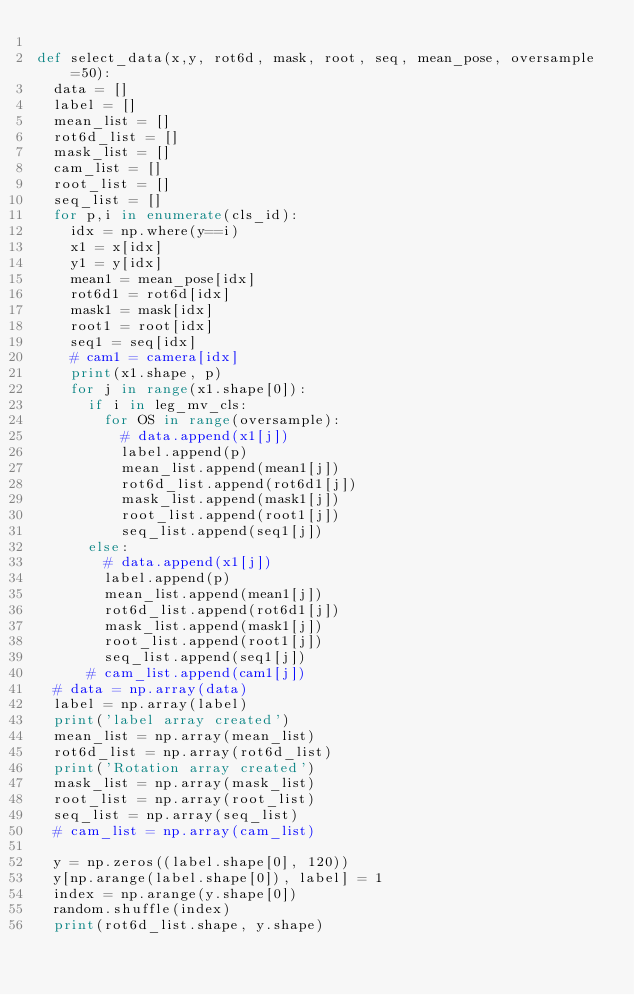<code> <loc_0><loc_0><loc_500><loc_500><_Python_>
def select_data(x,y, rot6d, mask, root, seq, mean_pose, oversample=50):
	data = []
	label = []
	mean_list = []
	rot6d_list = []
	mask_list = []
	cam_list = []
	root_list = []
	seq_list = []
	for p,i in enumerate(cls_id):
		idx = np.where(y==i)
		x1 = x[idx]
		y1 = y[idx]
		mean1 = mean_pose[idx]
		rot6d1 = rot6d[idx]
		mask1 = mask[idx]
		root1 = root[idx]
		seq1 = seq[idx]
		# cam1 = camera[idx]
		print(x1.shape, p)
		for j in range(x1.shape[0]):
			if i in leg_mv_cls:
				for OS in range(oversample):
					# data.append(x1[j])
					label.append(p)
					mean_list.append(mean1[j])
					rot6d_list.append(rot6d1[j])
					mask_list.append(mask1[j])
					root_list.append(root1[j])
					seq_list.append(seq1[j])
			else:
				# data.append(x1[j])
				label.append(p)
				mean_list.append(mean1[j])
				rot6d_list.append(rot6d1[j])
				mask_list.append(mask1[j])
				root_list.append(root1[j])
				seq_list.append(seq1[j])
			# cam_list.append(cam1[j])
	# data = np.array(data)
	label = np.array(label)
	print('label array created')
	mean_list = np.array(mean_list)
	rot6d_list = np.array(rot6d_list)
	print('Rotation array created')
	mask_list = np.array(mask_list)
	root_list = np.array(root_list)
	seq_list = np.array(seq_list)
	# cam_list = np.array(cam_list)

	y = np.zeros((label.shape[0], 120))
	y[np.arange(label.shape[0]), label] = 1
	index = np.arange(y.shape[0])
	random.shuffle(index)
	print(rot6d_list.shape, y.shape)</code> 